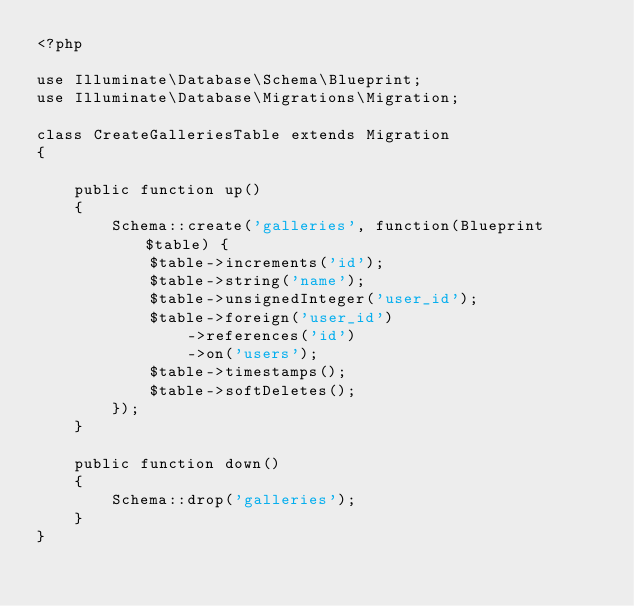Convert code to text. <code><loc_0><loc_0><loc_500><loc_500><_PHP_><?php

use Illuminate\Database\Schema\Blueprint;
use Illuminate\Database\Migrations\Migration;

class CreateGalleriesTable extends Migration
{

    public function up()
    {
        Schema::create('galleries', function(Blueprint $table) {
            $table->increments('id');
            $table->string('name');
            $table->unsignedInteger('user_id');
            $table->foreign('user_id')
                ->references('id')
                ->on('users');
            $table->timestamps();
            $table->softDeletes();
        });
    }

    public function down()
    {
        Schema::drop('galleries');
    }
}
</code> 